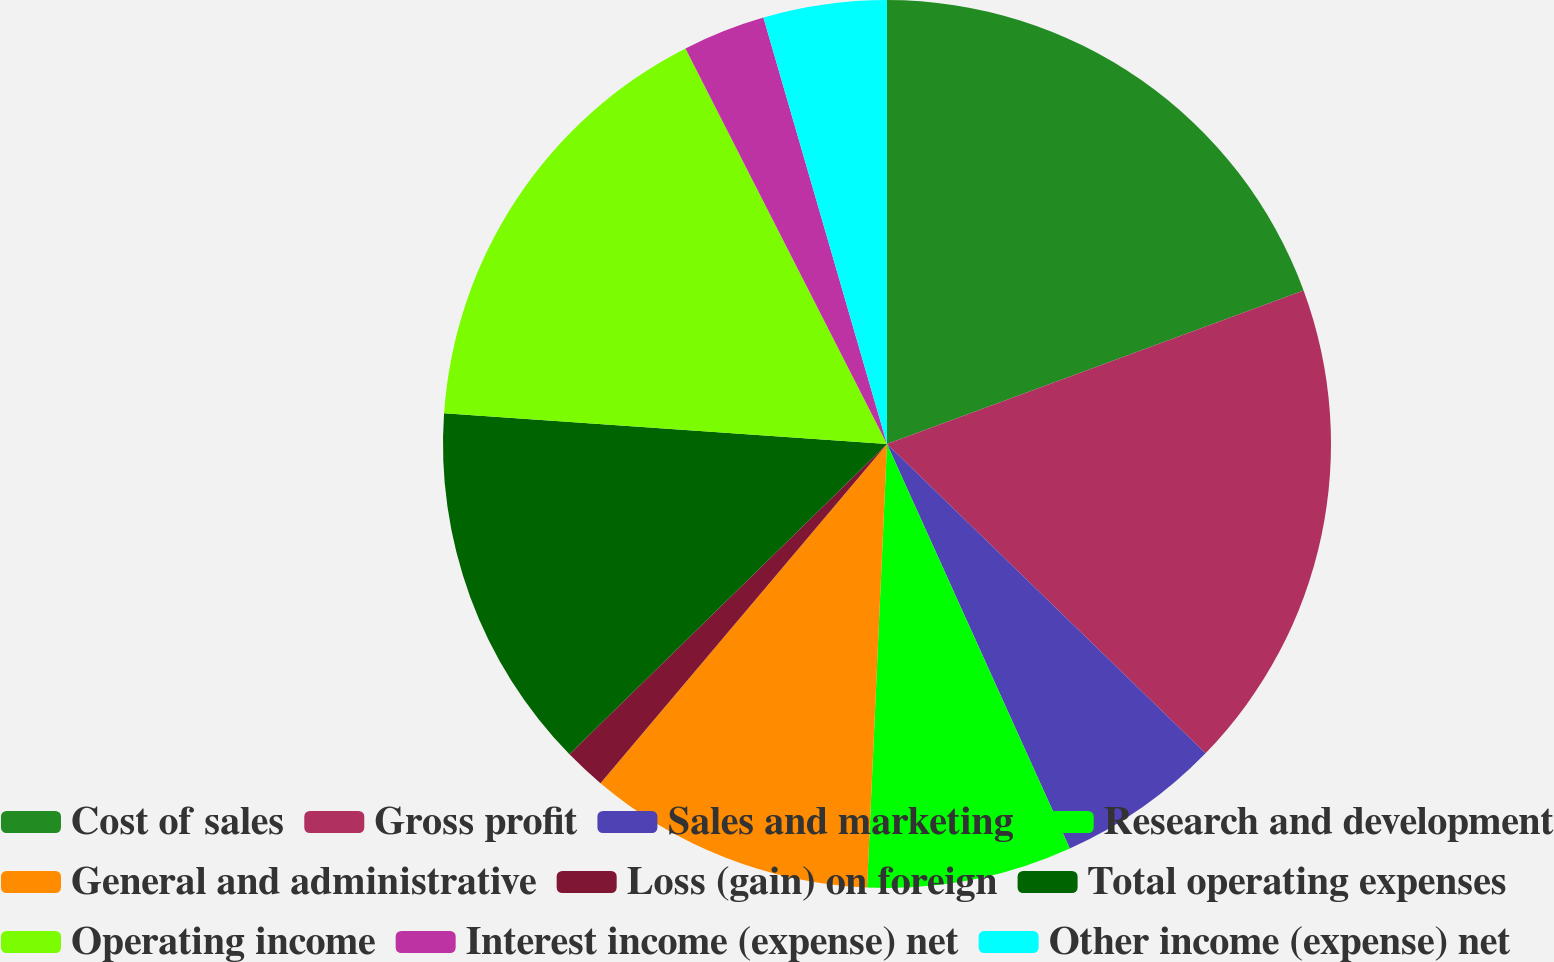<chart> <loc_0><loc_0><loc_500><loc_500><pie_chart><fcel>Cost of sales<fcel>Gross profit<fcel>Sales and marketing<fcel>Research and development<fcel>General and administrative<fcel>Loss (gain) on foreign<fcel>Total operating expenses<fcel>Operating income<fcel>Interest income (expense) net<fcel>Other income (expense) net<nl><fcel>19.38%<fcel>17.89%<fcel>5.98%<fcel>7.47%<fcel>10.45%<fcel>1.52%<fcel>13.42%<fcel>16.4%<fcel>3.01%<fcel>4.49%<nl></chart> 